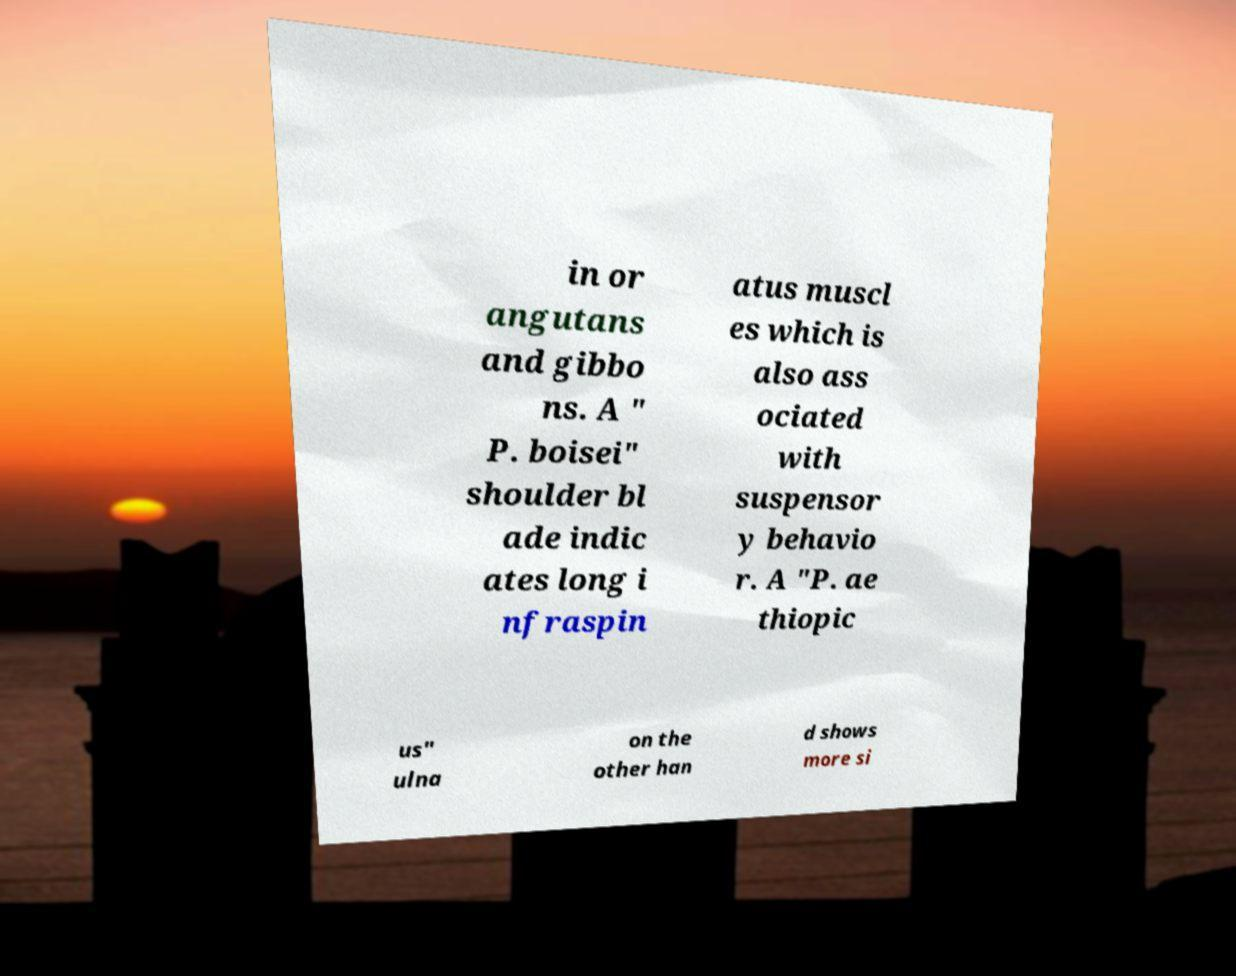There's text embedded in this image that I need extracted. Can you transcribe it verbatim? in or angutans and gibbo ns. A " P. boisei" shoulder bl ade indic ates long i nfraspin atus muscl es which is also ass ociated with suspensor y behavio r. A "P. ae thiopic us" ulna on the other han d shows more si 